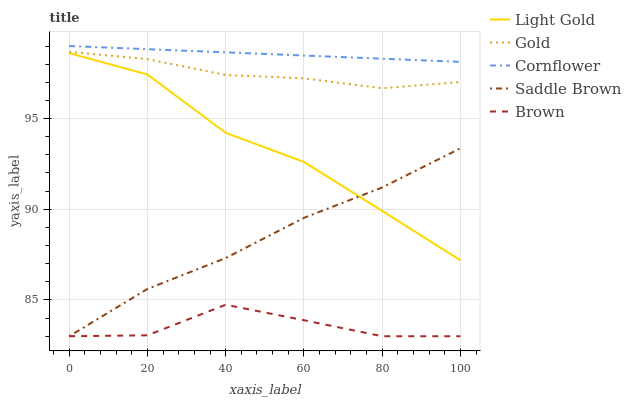Does Light Gold have the minimum area under the curve?
Answer yes or no. No. Does Light Gold have the maximum area under the curve?
Answer yes or no. No. Is Light Gold the smoothest?
Answer yes or no. No. Is Light Gold the roughest?
Answer yes or no. No. Does Light Gold have the lowest value?
Answer yes or no. No. Does Light Gold have the highest value?
Answer yes or no. No. Is Gold less than Cornflower?
Answer yes or no. Yes. Is Cornflower greater than Gold?
Answer yes or no. Yes. Does Gold intersect Cornflower?
Answer yes or no. No. 